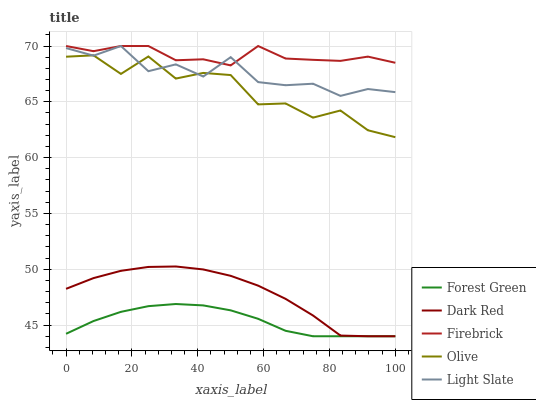Does Forest Green have the minimum area under the curve?
Answer yes or no. Yes. Does Firebrick have the maximum area under the curve?
Answer yes or no. Yes. Does Dark Red have the minimum area under the curve?
Answer yes or no. No. Does Dark Red have the maximum area under the curve?
Answer yes or no. No. Is Forest Green the smoothest?
Answer yes or no. Yes. Is Olive the roughest?
Answer yes or no. Yes. Is Dark Red the smoothest?
Answer yes or no. No. Is Dark Red the roughest?
Answer yes or no. No. Does Dark Red have the lowest value?
Answer yes or no. Yes. Does Firebrick have the lowest value?
Answer yes or no. No. Does Light Slate have the highest value?
Answer yes or no. Yes. Does Dark Red have the highest value?
Answer yes or no. No. Is Dark Red less than Firebrick?
Answer yes or no. Yes. Is Olive greater than Dark Red?
Answer yes or no. Yes. Does Firebrick intersect Light Slate?
Answer yes or no. Yes. Is Firebrick less than Light Slate?
Answer yes or no. No. Is Firebrick greater than Light Slate?
Answer yes or no. No. Does Dark Red intersect Firebrick?
Answer yes or no. No. 